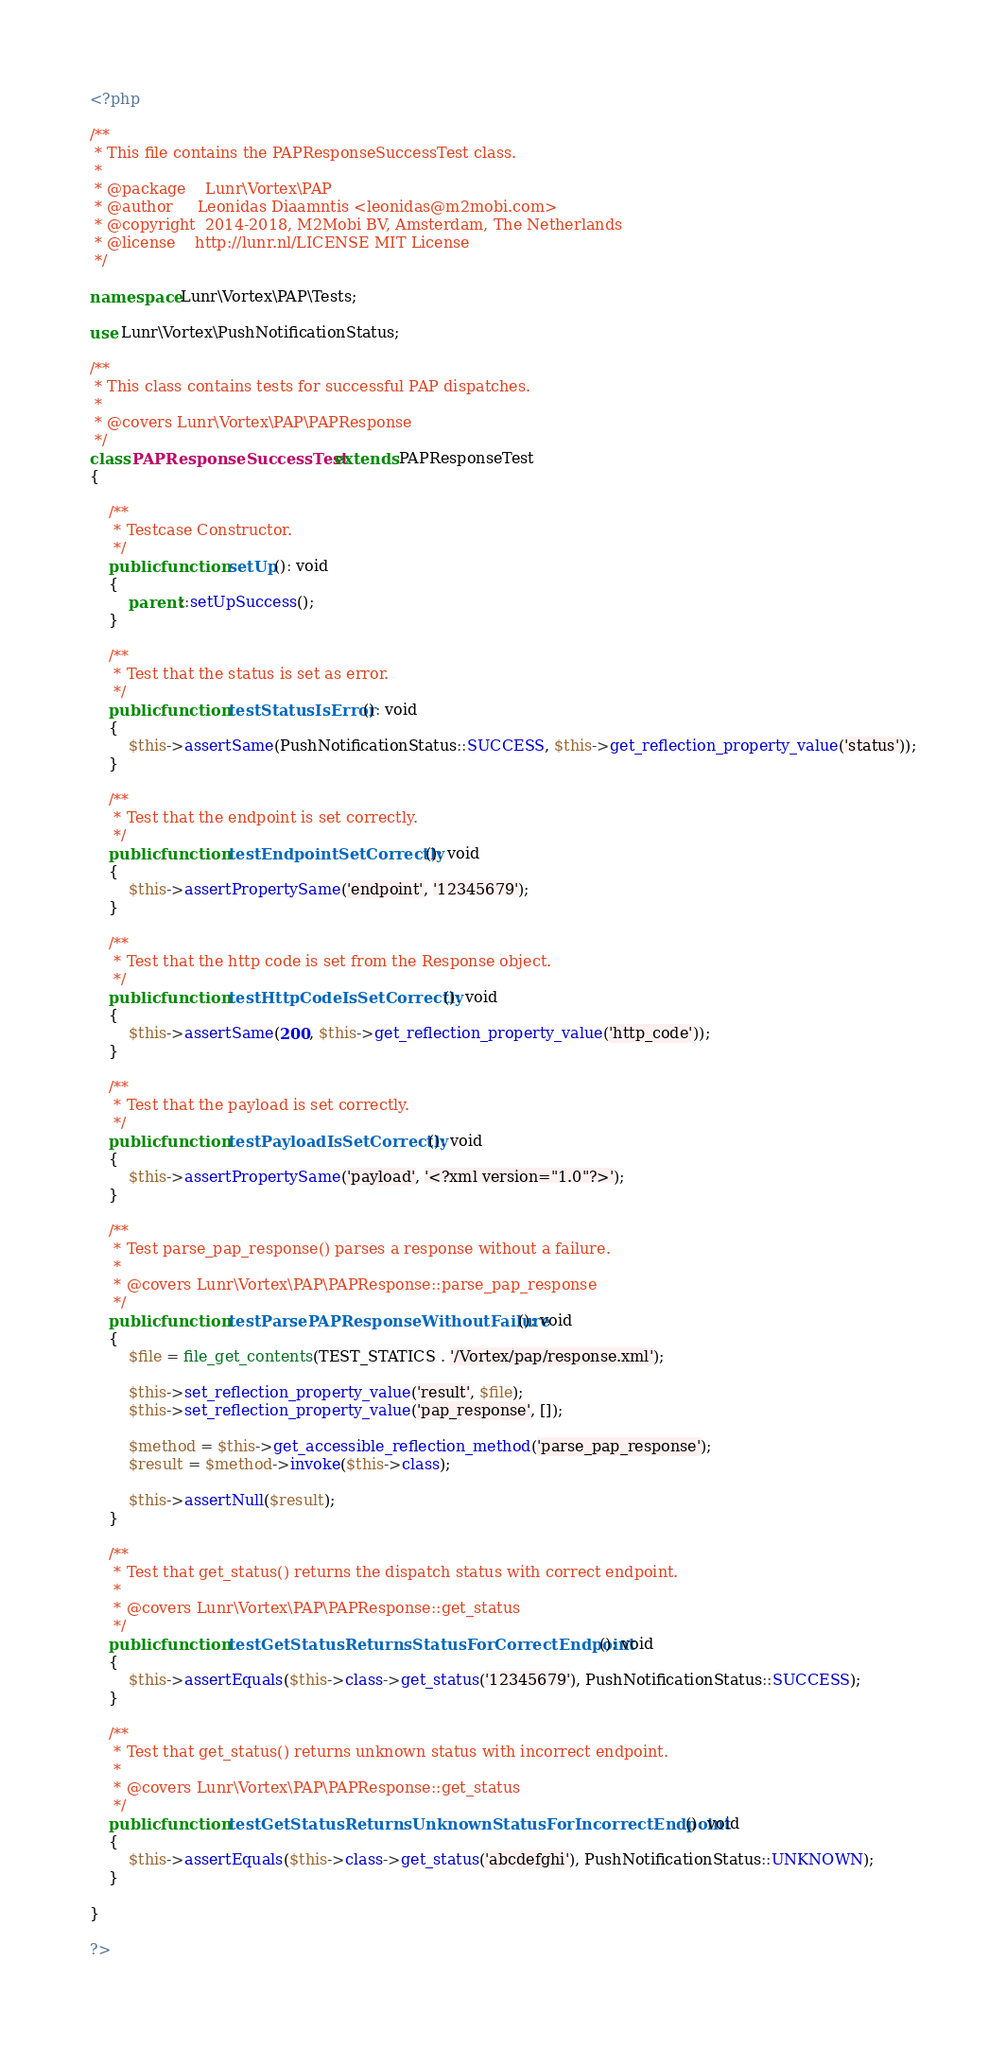Convert code to text. <code><loc_0><loc_0><loc_500><loc_500><_PHP_><?php

/**
 * This file contains the PAPResponseSuccessTest class.
 *
 * @package    Lunr\Vortex\PAP
 * @author     Leonidas Diaamntis <leonidas@m2mobi.com>
 * @copyright  2014-2018, M2Mobi BV, Amsterdam, The Netherlands
 * @license    http://lunr.nl/LICENSE MIT License
 */

namespace Lunr\Vortex\PAP\Tests;

use Lunr\Vortex\PushNotificationStatus;

/**
 * This class contains tests for successful PAP dispatches.
 *
 * @covers Lunr\Vortex\PAP\PAPResponse
 */
class PAPResponseSuccessTest extends PAPResponseTest
{

    /**
     * Testcase Constructor.
     */
    public function setUp(): void
    {
        parent::setUpSuccess();
    }

    /**
     * Test that the status is set as error.
     */
    public function testStatusIsError(): void
    {
        $this->assertSame(PushNotificationStatus::SUCCESS, $this->get_reflection_property_value('status'));
    }

    /**
     * Test that the endpoint is set correctly.
     */
    public function testEndpointSetCorrectly(): void
    {
        $this->assertPropertySame('endpoint', '12345679');
    }

    /**
     * Test that the http code is set from the Response object.
     */
    public function testHttpCodeIsSetCorrectly(): void
    {
        $this->assertSame(200, $this->get_reflection_property_value('http_code'));
    }

    /**
     * Test that the payload is set correctly.
     */
    public function testPayloadIsSetCorrectly(): void
    {
        $this->assertPropertySame('payload', '<?xml version="1.0"?>');
    }

    /**
     * Test parse_pap_response() parses a response without a failure.
     *
     * @covers Lunr\Vortex\PAP\PAPResponse::parse_pap_response
     */
    public function testParsePAPResponseWithoutFailure(): void
    {
        $file = file_get_contents(TEST_STATICS . '/Vortex/pap/response.xml');

        $this->set_reflection_property_value('result', $file);
        $this->set_reflection_property_value('pap_response', []);

        $method = $this->get_accessible_reflection_method('parse_pap_response');
        $result = $method->invoke($this->class);

        $this->assertNull($result);
    }

    /**
     * Test that get_status() returns the dispatch status with correct endpoint.
     *
     * @covers Lunr\Vortex\PAP\PAPResponse::get_status
     */
    public function testGetStatusReturnsStatusForCorrectEndpoint(): void
    {
        $this->assertEquals($this->class->get_status('12345679'), PushNotificationStatus::SUCCESS);
    }

    /**
     * Test that get_status() returns unknown status with incorrect endpoint.
     *
     * @covers Lunr\Vortex\PAP\PAPResponse::get_status
     */
    public function testGetStatusReturnsUnknownStatusForIncorrectEndpoint(): void
    {
        $this->assertEquals($this->class->get_status('abcdefghi'), PushNotificationStatus::UNKNOWN);
    }

}

?>
</code> 